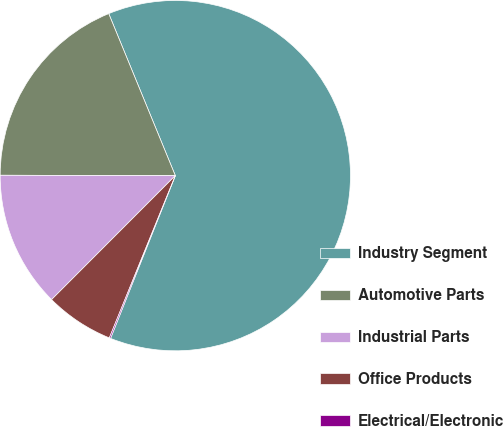<chart> <loc_0><loc_0><loc_500><loc_500><pie_chart><fcel>Industry Segment<fcel>Automotive Parts<fcel>Industrial Parts<fcel>Office Products<fcel>Electrical/Electronic<nl><fcel>62.24%<fcel>18.76%<fcel>12.55%<fcel>6.34%<fcel>0.12%<nl></chart> 